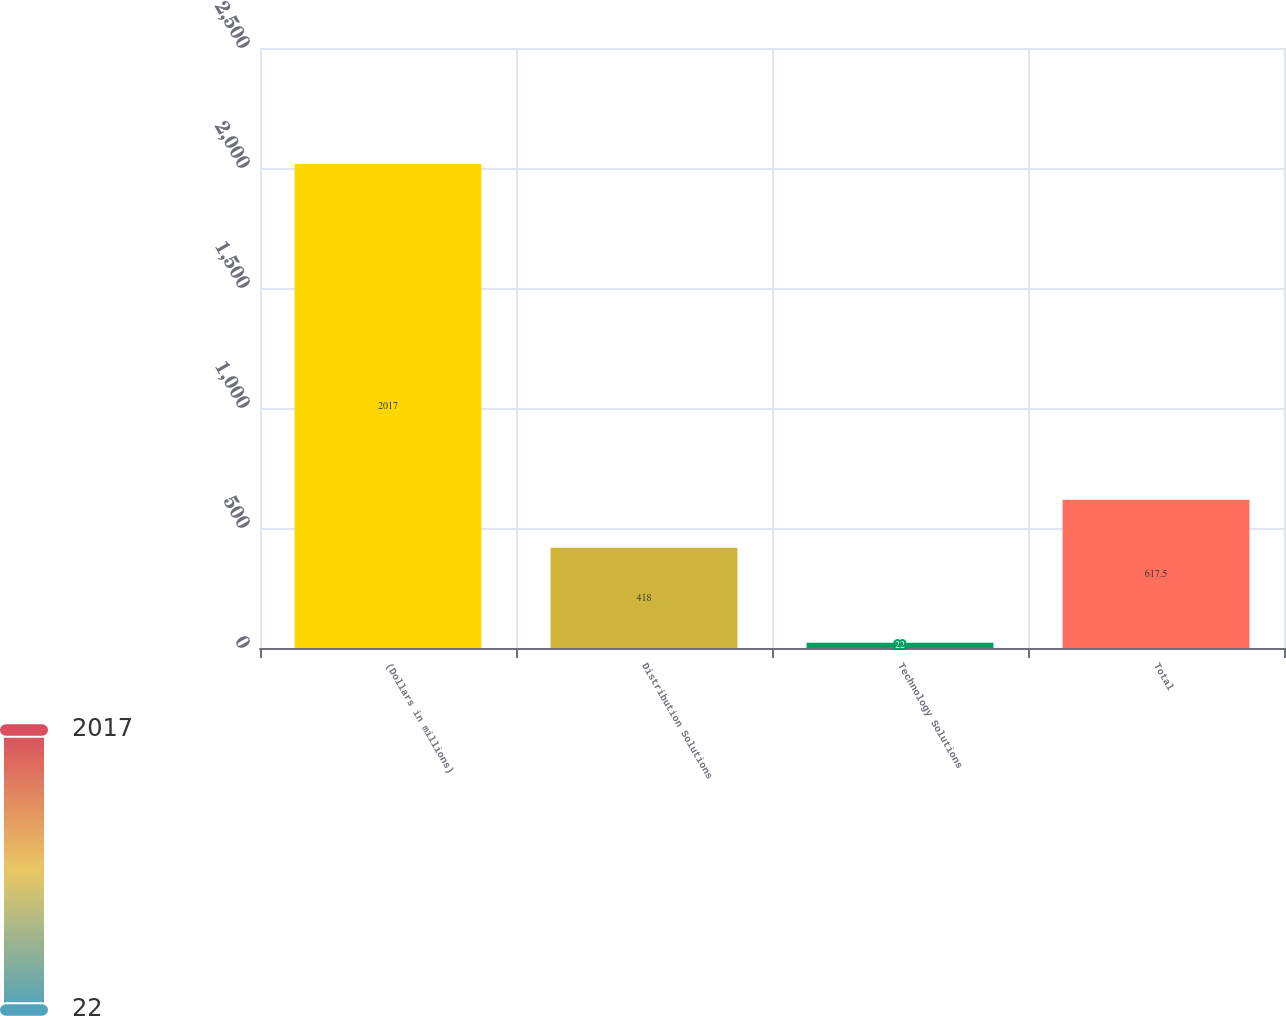Convert chart. <chart><loc_0><loc_0><loc_500><loc_500><bar_chart><fcel>(Dollars in millions)<fcel>Distribution Solutions<fcel>Technology Solutions<fcel>Total<nl><fcel>2017<fcel>418<fcel>22<fcel>617.5<nl></chart> 